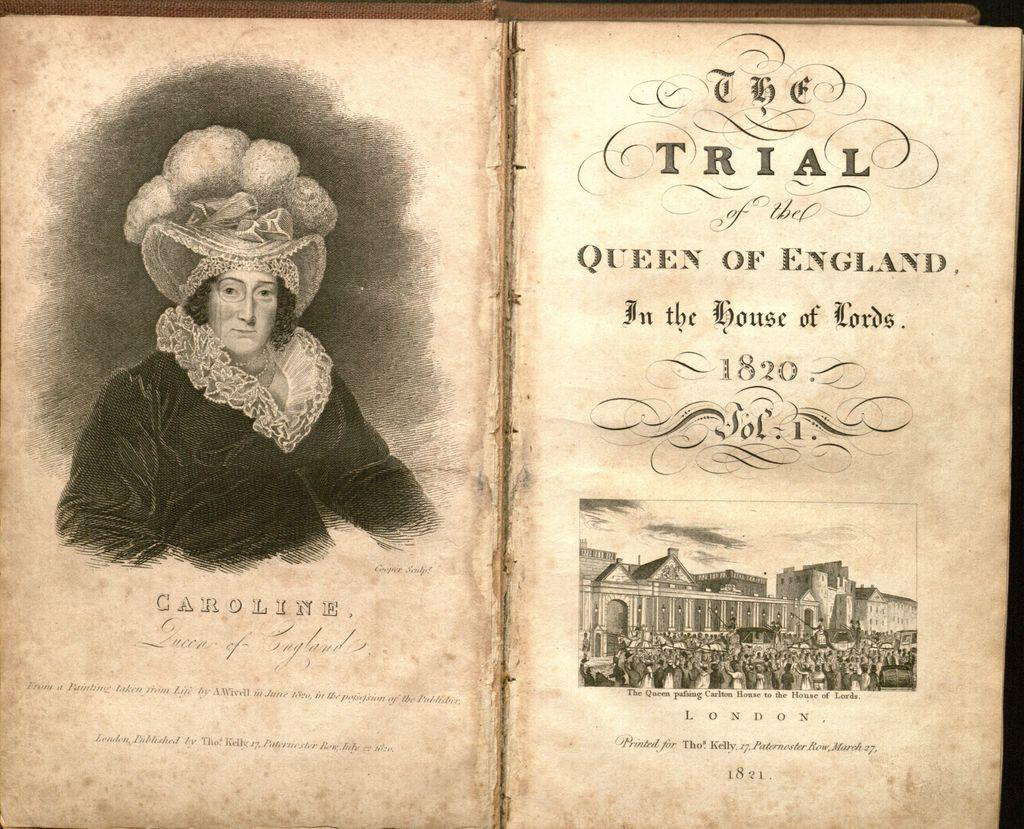Provide a one-sentence caption for the provided image. An open old book titled The Trial of the Queen of England in the House of Lords 1820. 